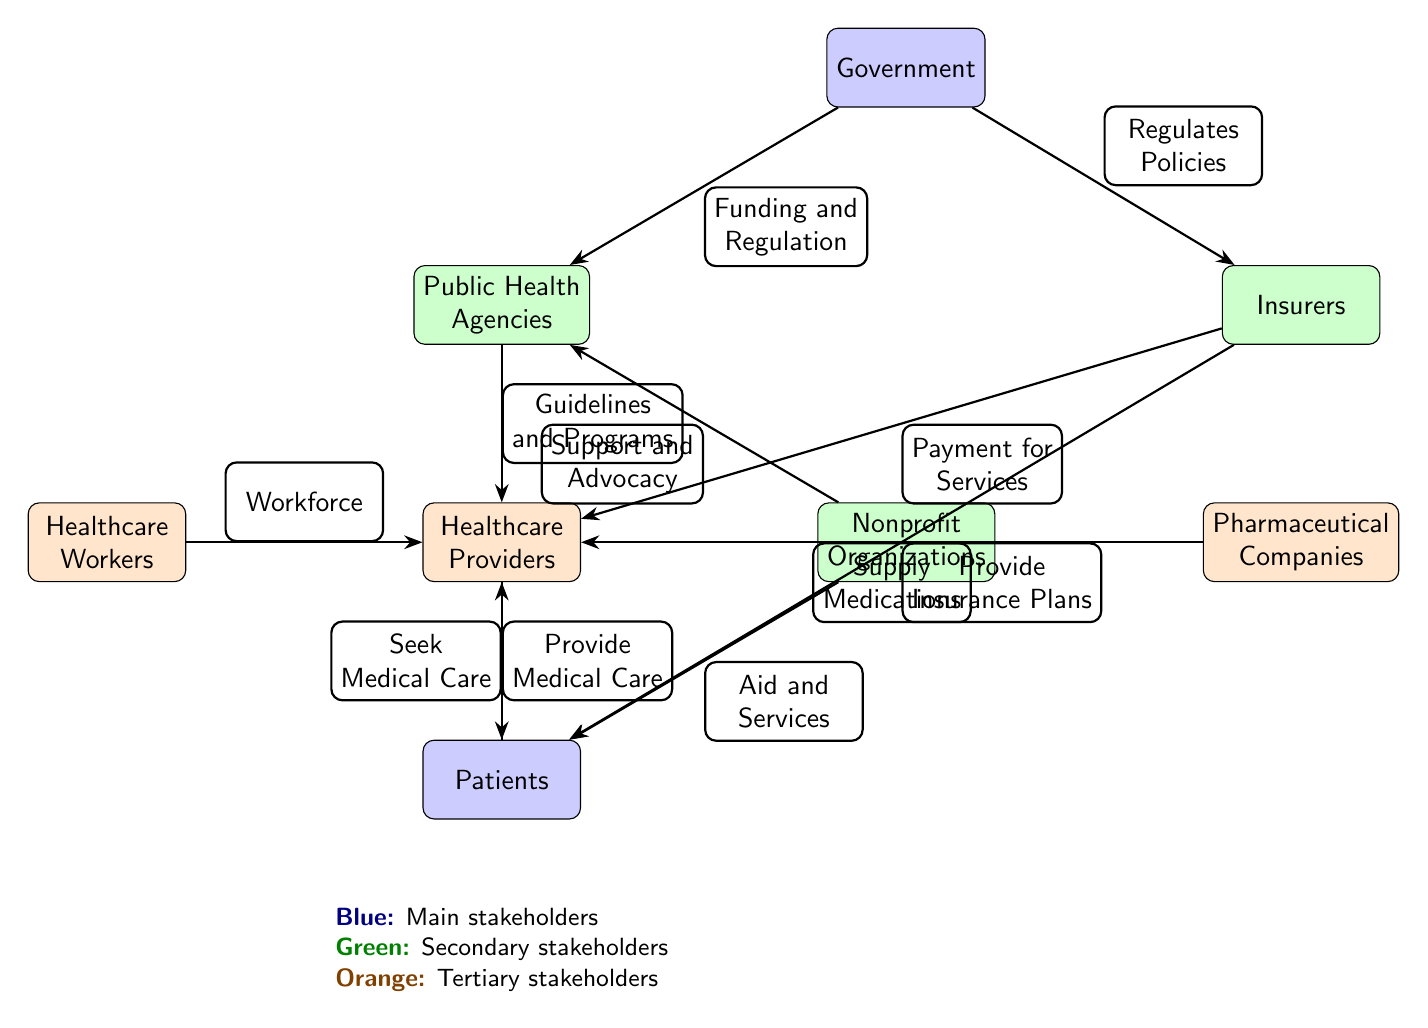What is the top node in the diagram? The diagram has a clear hierarchical structure, with the Government node located at the top.
Answer: Government How many tertiary stakeholders are represented in the diagram? By examining the diagram, we can find three tertiary stakeholders: Healthcare Workers, Pharmaceutical Companies, and Patients.
Answer: 3 What role does the Government play in relation to Public Health Agencies? The diagram shows an edge labeled "Funding and Regulation" from the Government node to the Public Health Agencies node, indicating that the Government provides funding and regulation for these agencies.
Answer: Funding and Regulation Which stakeholder aids patients directly? The diagram indicates that Nonprofit Organizations have a direct edge labeled "Aid and Services" towards the Patients node, showing their support role.
Answer: Nonprofit Organizations What flows from Insurers to Healthcare Providers? Observing the connections in the diagram, we can see an edge from Insurers to Healthcare Providers labeled "Payment for Services," which indicates the relationship between these stakeholders.
Answer: Payment for Services How do Public Health Agencies interact with Healthcare Providers? The connection between these two nodes is established by the edge labeled "Guidelines and Programs," implying the role of Public Health Agencies in providing guidance to Healthcare Providers.
Answer: Guidelines and Programs What node is connected to both Healthcare Providers and Patients? The diagram shows the Healthcare Providers node connected to the Patients node, indicating that both interact with each other through the provision of medical care as shown by the edge labeled "Provide Medical Care."
Answer: Healthcare Providers What is the main purpose of the Pharmaceutical Companies in this structure? The edge drawn from Pharmaceutical Companies to Healthcare Providers is labeled "Supply Medications," indicating that their primary role is to provide necessary medications to healthcare providers.
Answer: Supply Medications What do Patients do in relation to Healthcare Providers? The relationship is clearly indicated by the edge labeled "Seek Medical Care," showing that Patients actively seek care from Healthcare Providers.
Answer: Seek Medical Care 